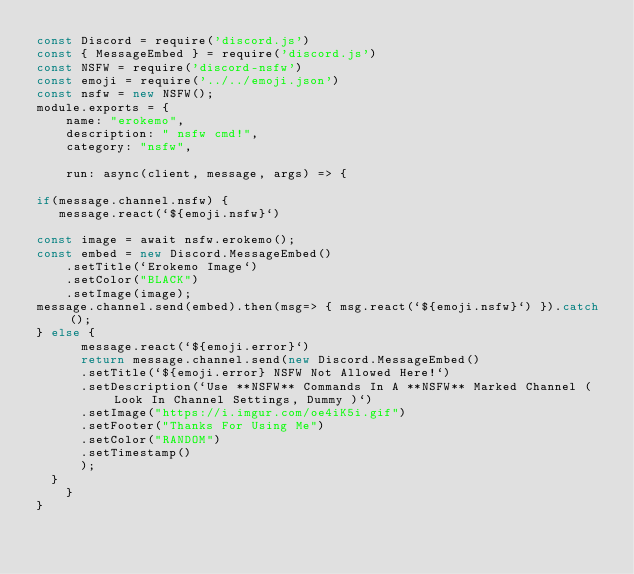<code> <loc_0><loc_0><loc_500><loc_500><_JavaScript_>const Discord = require('discord.js')
const { MessageEmbed } = require('discord.js')
const NSFW = require('discord-nsfw')
const emoji = require('../../emoji.json')
const nsfw = new NSFW();
module.exports = {
    name: "erokemo",
    description: " nsfw cmd!",
    category: "nsfw",

    run: async(client, message, args) => {

if(message.channel.nsfw) {
   message.react(`${emoji.nsfw}`)

const image = await nsfw.erokemo();
const embed = new Discord.MessageEmbed()
    .setTitle(`Erokemo Image`)
    .setColor("BLACK")
    .setImage(image);
message.channel.send(embed).then(msg=> { msg.react(`${emoji.nsfw}`) }).catch();
} else {
      message.react(`${emoji.error}`)
      return message.channel.send(new Discord.MessageEmbed()
      .setTitle(`${emoji.error} NSFW Not Allowed Here!`)
      .setDescription(`Use **NSFW** Commands In A **NSFW** Marked Channel ( Look In Channel Settings, Dummy )`)
      .setImage("https://i.imgur.com/oe4iK5i.gif")
      .setFooter("Thanks For Using Me")
      .setColor("RANDOM")
      .setTimestamp()
      );
  }
    }
}</code> 